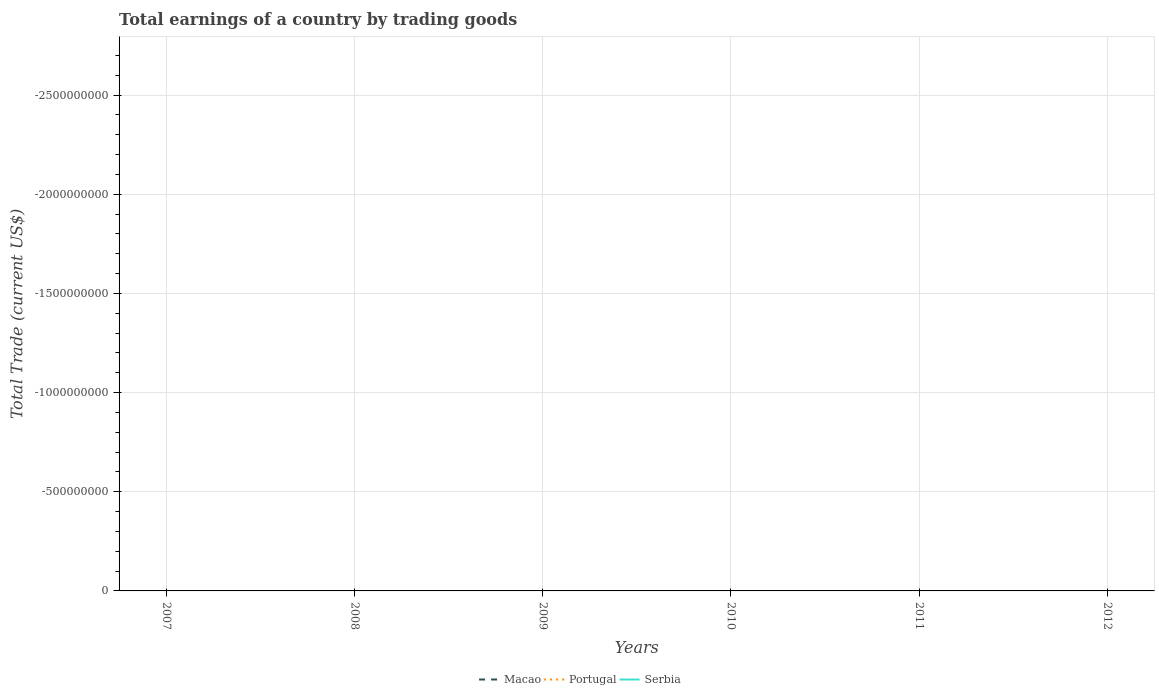Is the number of lines equal to the number of legend labels?
Your answer should be compact. No. Is the total earnings in Serbia strictly greater than the total earnings in Macao over the years?
Keep it short and to the point. No. What is the title of the graph?
Ensure brevity in your answer.  Total earnings of a country by trading goods. What is the label or title of the Y-axis?
Ensure brevity in your answer.  Total Trade (current US$). What is the Total Trade (current US$) of Macao in 2008?
Your answer should be compact. 0. What is the Total Trade (current US$) in Serbia in 2008?
Your answer should be compact. 0. What is the Total Trade (current US$) in Macao in 2009?
Provide a short and direct response. 0. What is the Total Trade (current US$) of Portugal in 2009?
Your response must be concise. 0. What is the Total Trade (current US$) of Serbia in 2009?
Provide a succinct answer. 0. What is the Total Trade (current US$) of Serbia in 2012?
Your response must be concise. 0. What is the total Total Trade (current US$) of Macao in the graph?
Your answer should be very brief. 0. What is the total Total Trade (current US$) in Portugal in the graph?
Give a very brief answer. 0. What is the average Total Trade (current US$) in Macao per year?
Offer a terse response. 0. What is the average Total Trade (current US$) of Portugal per year?
Make the answer very short. 0. 